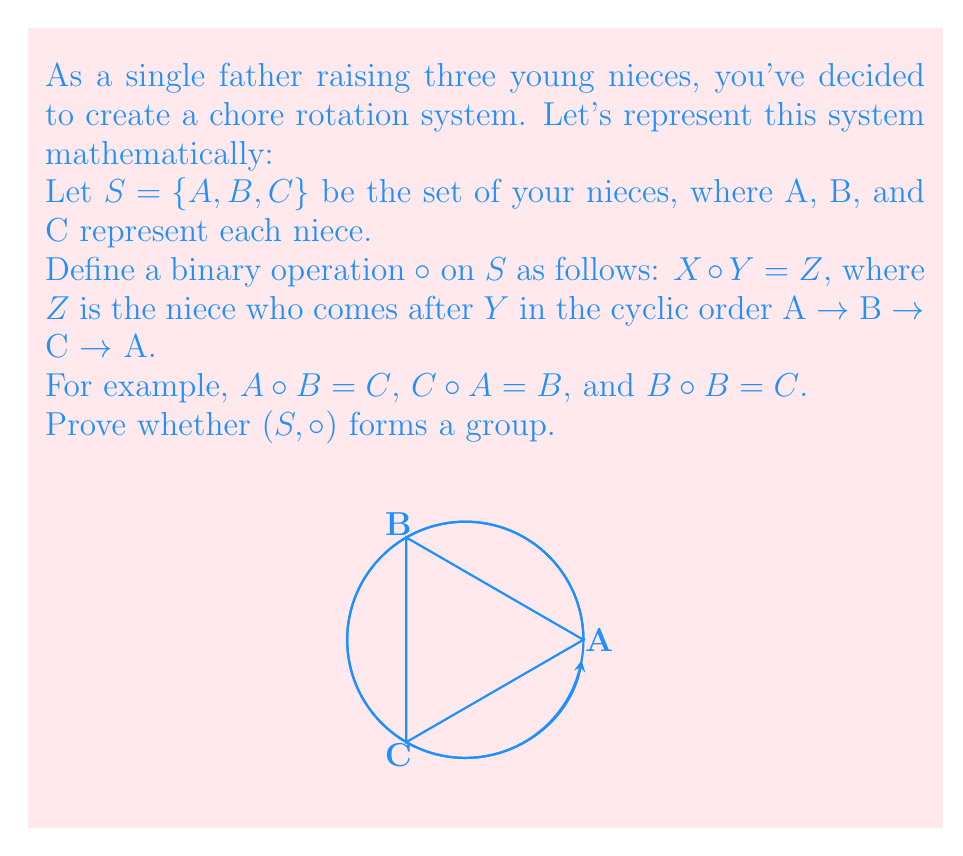Give your solution to this math problem. To prove whether $(S, \circ)$ forms a group, we need to check four group axioms:

1. Closure: For all $X, Y \in S$, $X \circ Y \in S$
2. Associativity: For all $X, Y, Z \in S$, $(X \circ Y) \circ Z = X \circ (Y \circ Z)$
3. Identity element: There exists an $e \in S$ such that $X \circ e = e \circ X = X$ for all $X \in S$
4. Inverse element: For each $X \in S$, there exists a $Y \in S$ such that $X \circ Y = Y \circ X = e$

Let's check each axiom:

1. Closure: 
   The operation always results in an element of $S$, so closure is satisfied.

2. Associativity:
   Let's check all possible combinations:
   $(A \circ B) \circ C = C \circ C = A = A \circ (B \circ C)$
   $(A \circ C) \circ B = B \circ B = C = A \circ (C \circ B)$
   $(B \circ A) \circ C = C \circ C = A = B \circ (A \circ C)$
   $(B \circ C) \circ A = A \circ A = B = B \circ (C \circ A)$
   $(C \circ A) \circ B = B \circ B = C = C \circ (A \circ B)$
   $(C \circ B) \circ A = A \circ A = B = C \circ (B \circ A)$
   Associativity is satisfied.

3. Identity element:
   There is no element $e \in S$ such that $X \circ e = e \circ X = X$ for all $X \in S$.
   For example, $A \circ A = B \neq A$, $B \circ B = C \neq B$, and $C \circ C = A \neq C$.
   Therefore, there is no identity element.

4. Inverse element:
   Since there is no identity element, we cannot define inverse elements.
Answer: $(S, \circ)$ does not form a group because it lacks an identity element and inverse elements. 